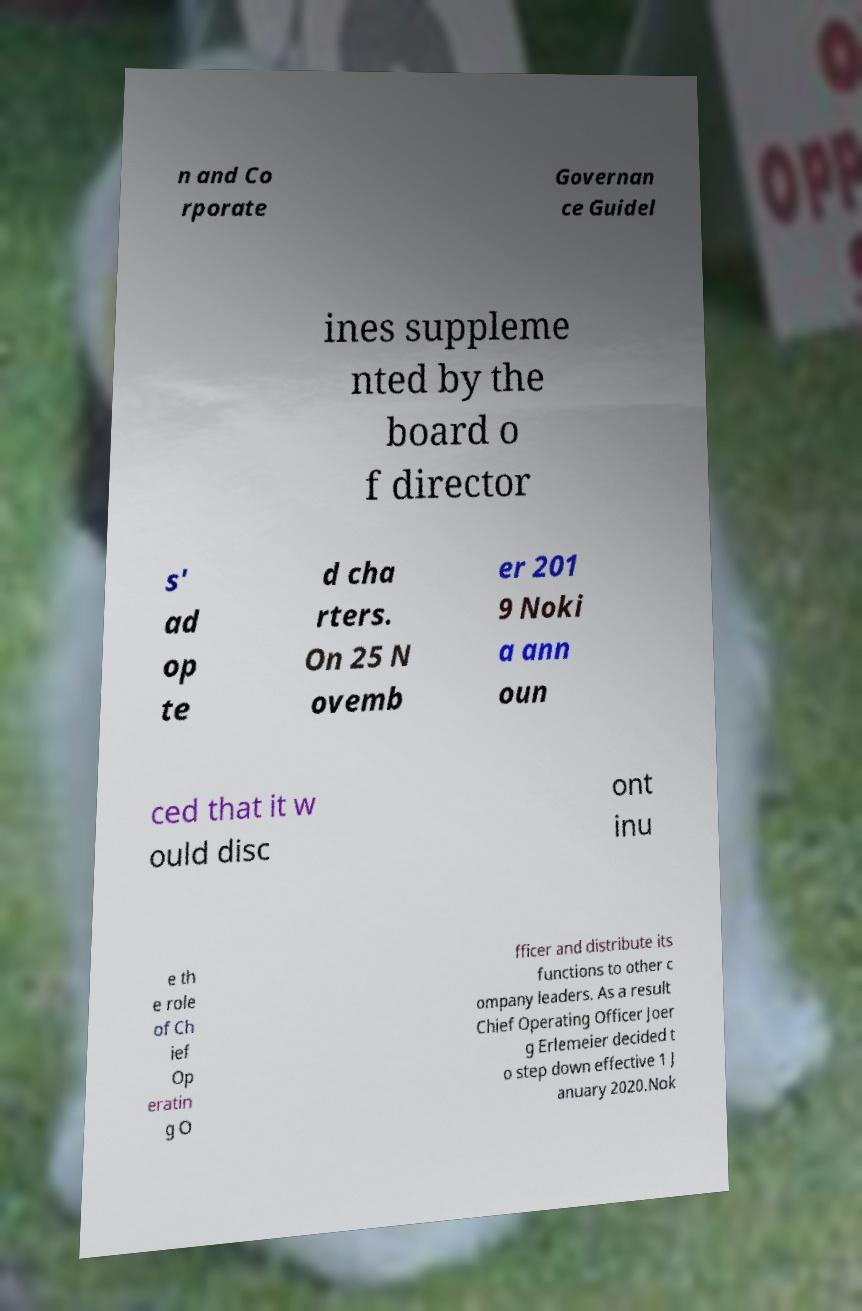Can you accurately transcribe the text from the provided image for me? n and Co rporate Governan ce Guidel ines suppleme nted by the board o f director s' ad op te d cha rters. On 25 N ovemb er 201 9 Noki a ann oun ced that it w ould disc ont inu e th e role of Ch ief Op eratin g O fficer and distribute its functions to other c ompany leaders. As a result Chief Operating Officer Joer g Erlemeier decided t o step down effective 1 J anuary 2020.Nok 